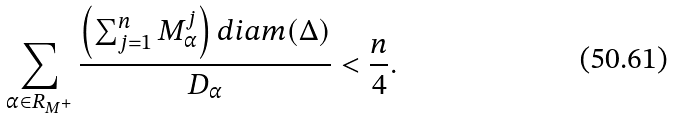Convert formula to latex. <formula><loc_0><loc_0><loc_500><loc_500>\sum _ { \alpha \in R _ { M ^ { + } } } \frac { \left ( \sum _ { j = 1 } ^ { n } M _ { \alpha } ^ { j } \right ) d i a m ( \Delta ) } { D _ { \alpha } } < \frac { n } { 4 } .</formula> 